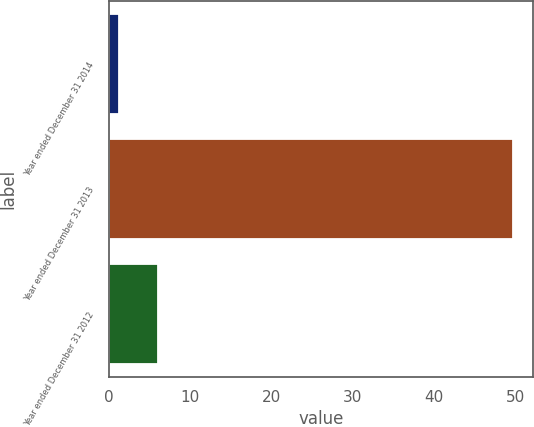Convert chart to OTSL. <chart><loc_0><loc_0><loc_500><loc_500><bar_chart><fcel>Year ended December 31 2014<fcel>Year ended December 31 2013<fcel>Year ended December 31 2012<nl><fcel>1.2<fcel>49.7<fcel>6.05<nl></chart> 